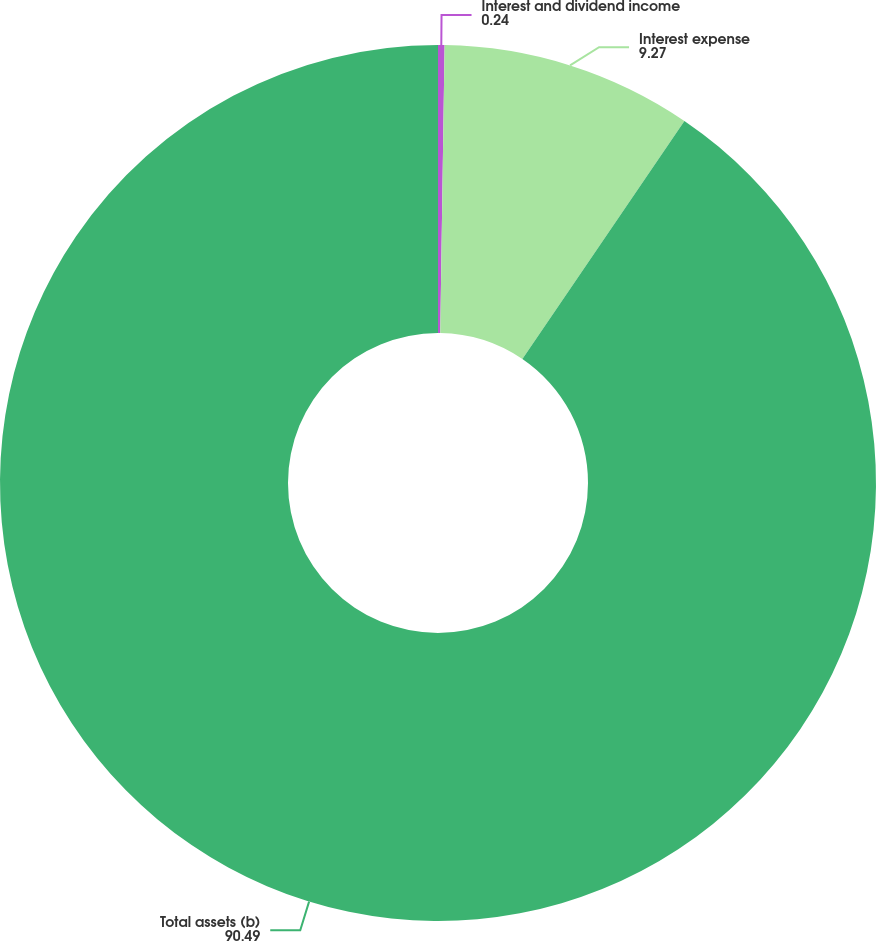Convert chart. <chart><loc_0><loc_0><loc_500><loc_500><pie_chart><fcel>Interest and dividend income<fcel>Interest expense<fcel>Total assets (b)<nl><fcel>0.24%<fcel>9.27%<fcel>90.49%<nl></chart> 